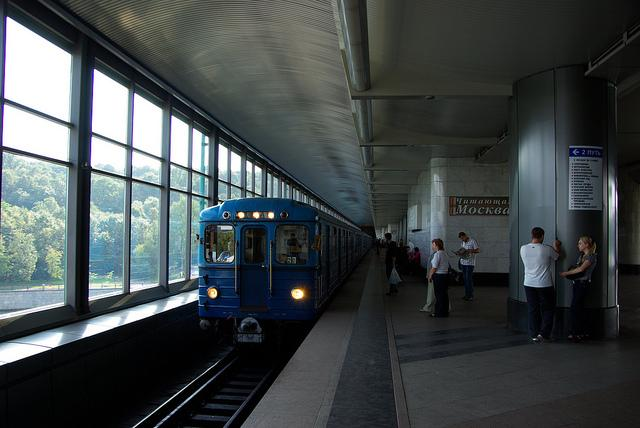What country is this location? Please explain your reasoning. russia. The country is russia. 